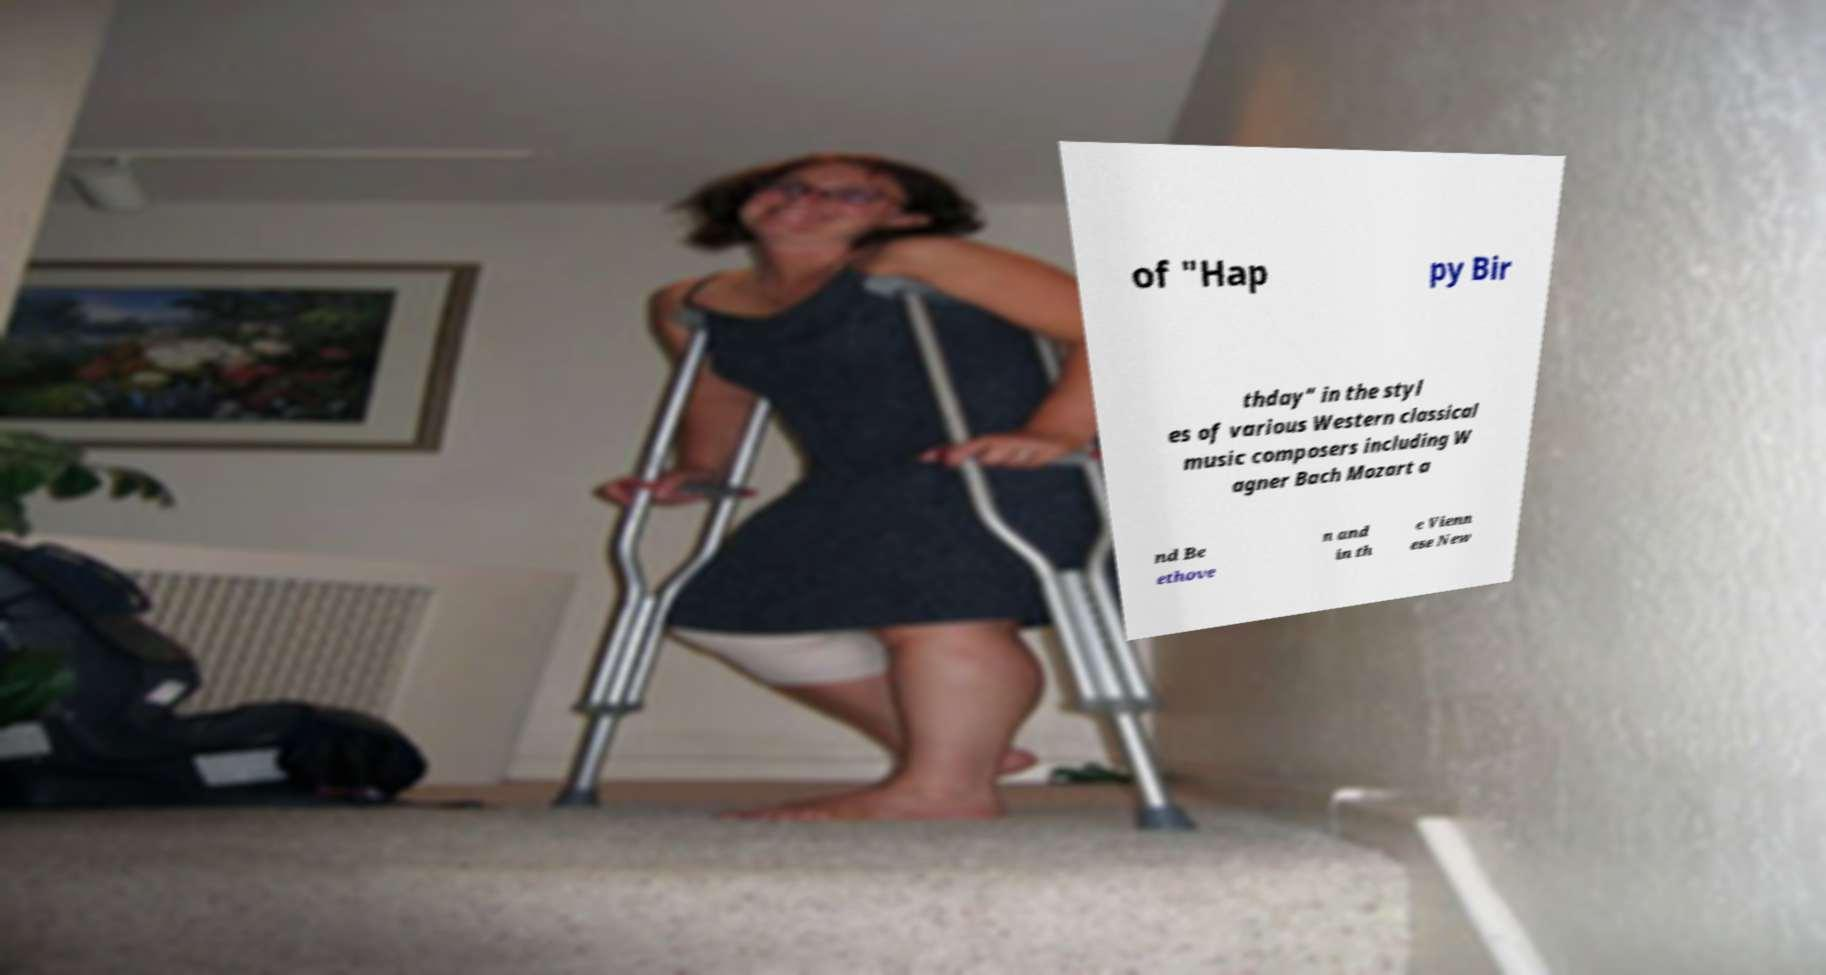For documentation purposes, I need the text within this image transcribed. Could you provide that? of "Hap py Bir thday" in the styl es of various Western classical music composers including W agner Bach Mozart a nd Be ethove n and in th e Vienn ese New 